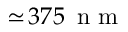Convert formula to latex. <formula><loc_0><loc_0><loc_500><loc_500>\simeq \, 3 7 5 { \, n m }</formula> 